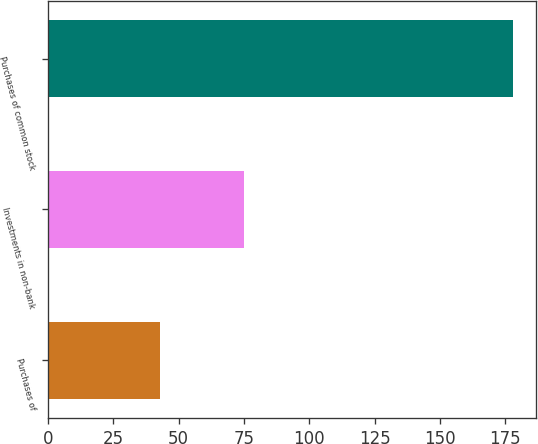Convert chart to OTSL. <chart><loc_0><loc_0><loc_500><loc_500><bar_chart><fcel>Purchases of<fcel>Investments in non-bank<fcel>Purchases of common stock<nl><fcel>43<fcel>75<fcel>178<nl></chart> 